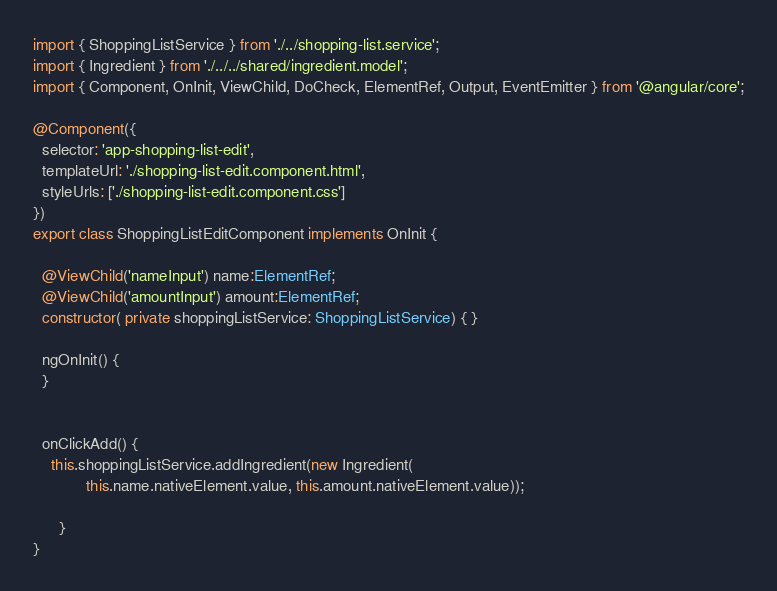<code> <loc_0><loc_0><loc_500><loc_500><_TypeScript_>import { ShoppingListService } from './../shopping-list.service';
import { Ingredient } from './../../shared/ingredient.model';
import { Component, OnInit, ViewChild, DoCheck, ElementRef, Output, EventEmitter } from '@angular/core';

@Component({
  selector: 'app-shopping-list-edit',
  templateUrl: './shopping-list-edit.component.html',
  styleUrls: ['./shopping-list-edit.component.css']
})
export class ShoppingListEditComponent implements OnInit {

  @ViewChild('nameInput') name:ElementRef;
  @ViewChild('amountInput') amount:ElementRef;
  constructor( private shoppingListService: ShoppingListService) { }

  ngOnInit() {
  }

  
  onClickAdd() {
    this.shoppingListService.addIngredient(new Ingredient(
            this.name.nativeElement.value, this.amount.nativeElement.value));

      }
}
</code> 